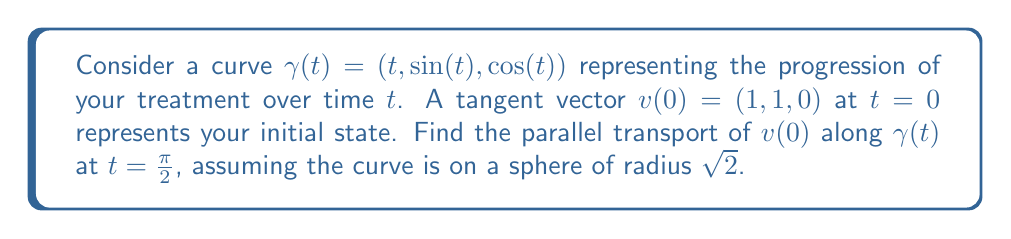Help me with this question. 1) First, we need to calculate the tangent vector $T(t)$ to the curve:
   $$T(t) = \gamma'(t) = (1, \cos(t), -\sin(t))$$

2) The normal vector $N(t)$ to the sphere at $\gamma(t)$ is:
   $$N(t) = \frac{\gamma(t)}{\|\gamma(t)\|} = \frac{1}{\sqrt{2}}(t, \sin(t), \cos(t))$$

3) The parallel transport equation for a vector $v(t)$ along $\gamma(t)$ is:
   $$\frac{dv}{dt} = -\langle \frac{dv}{dt}, N \rangle N$$

4) We can write $v(t) = a(t)T(t) + b(t)N(t) + c(t)(T(t) \times N(t))$

5) Due to parallel transport properties:
   - $\langle v(t), T(t) \rangle$ is constant
   - $\langle v(t), N(t) \rangle$ is constant
   - $\|v(t)\|$ is constant

6) Using these properties:
   $$a(t) = \langle v(0), T(0) \rangle = 1$$
   $$b(t) = \langle v(0), N(0) \rangle = \frac{1}{\sqrt{2}}$$
   $$c(t)^2 = \|v(0)\|^2 - a(t)^2 - b(t)^2 = 2 - 1 - \frac{1}{2} = \frac{1}{2}$$

7) At $t=\pi/2$:
   $$T(\pi/2) = (1, 0, -1)$$
   $$N(\pi/2) = \frac{1}{\sqrt{2}}(\frac{\pi}{2}, 1, 0)$$
   $$T(\pi/2) \times N(\pi/2) = \frac{1}{\sqrt{2}}(-1, \frac{\pi}{2}, 1)$$

8) Therefore, the parallel transport of $v(0)$ at $t=\pi/2$ is:
   $$v(\pi/2) = 1(1, 0, -1) + \frac{1}{\sqrt{2}}(\frac{\pi}{2}, 1, 0) + \frac{1}{\sqrt{2}}(-1, \frac{\pi}{2}, 1)$$
Answer: $v(\pi/2) = (1 + \frac{\pi}{2\sqrt{2}} - \frac{1}{\sqrt{2}}, \frac{1}{\sqrt{2}} + \frac{\pi}{2\sqrt{2}}, -1 + \frac{1}{\sqrt{2}})$ 